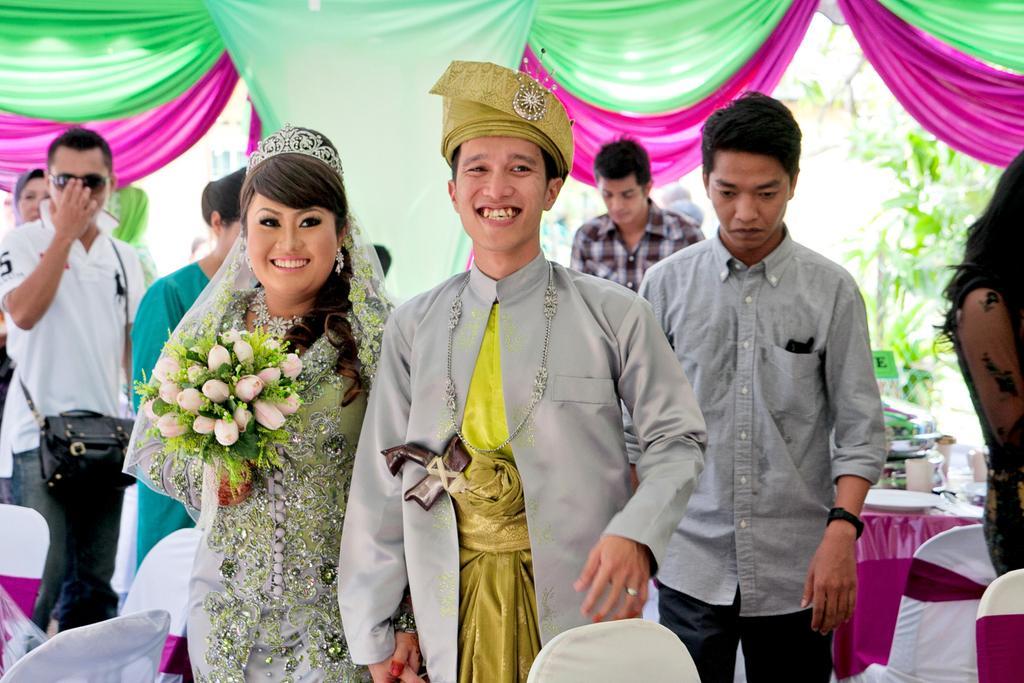In one or two sentences, can you explain what this image depicts? In this picture we can see a man and a woman holding hands and smiling and at the back of them we can see a group of people standing, bag, goggles, chairs, tables, crown, flower bouquet, trees, curtains, sword and some objects. 